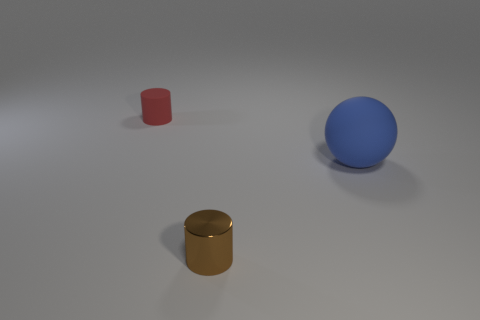Is there any other thing that has the same size as the sphere?
Your answer should be compact. No. There is a tiny cylinder in front of the matte object right of the cylinder to the right of the red rubber cylinder; what is it made of?
Provide a succinct answer. Metal. Does the small thing that is in front of the small matte cylinder have the same shape as the tiny red matte object?
Offer a terse response. Yes. There is a tiny object that is in front of the blue sphere; what is it made of?
Offer a very short reply. Metal. What number of matte objects are either small cubes or big balls?
Keep it short and to the point. 1. Is there a matte cylinder that has the same size as the brown thing?
Your answer should be very brief. Yes. Are there more rubber objects right of the brown metal object than yellow metal objects?
Offer a very short reply. Yes. What number of big objects are either purple spheres or red matte cylinders?
Your answer should be compact. 0. What number of blue rubber objects are the same shape as the brown shiny object?
Ensure brevity in your answer.  0. What is the material of the small cylinder in front of the small object that is behind the big blue thing?
Provide a short and direct response. Metal. 